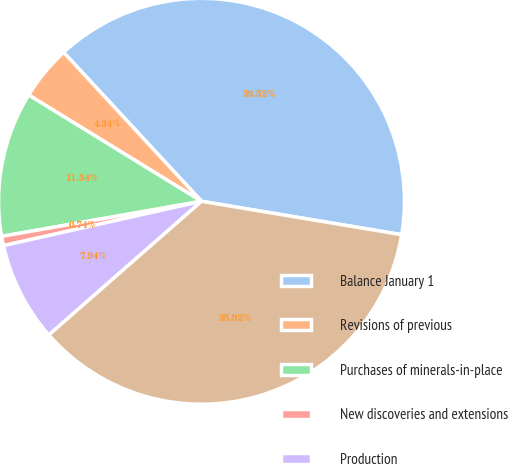<chart> <loc_0><loc_0><loc_500><loc_500><pie_chart><fcel>Balance January 1<fcel>Revisions of previous<fcel>Purchases of minerals-in-place<fcel>New discoveries and extensions<fcel>Production<fcel>Balance December 31<nl><fcel>39.52%<fcel>4.34%<fcel>11.54%<fcel>0.74%<fcel>7.94%<fcel>35.92%<nl></chart> 